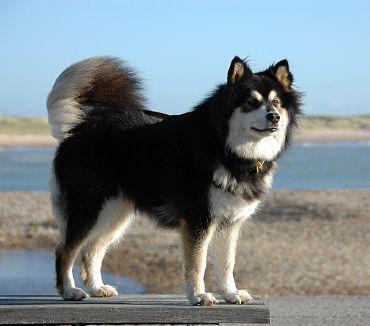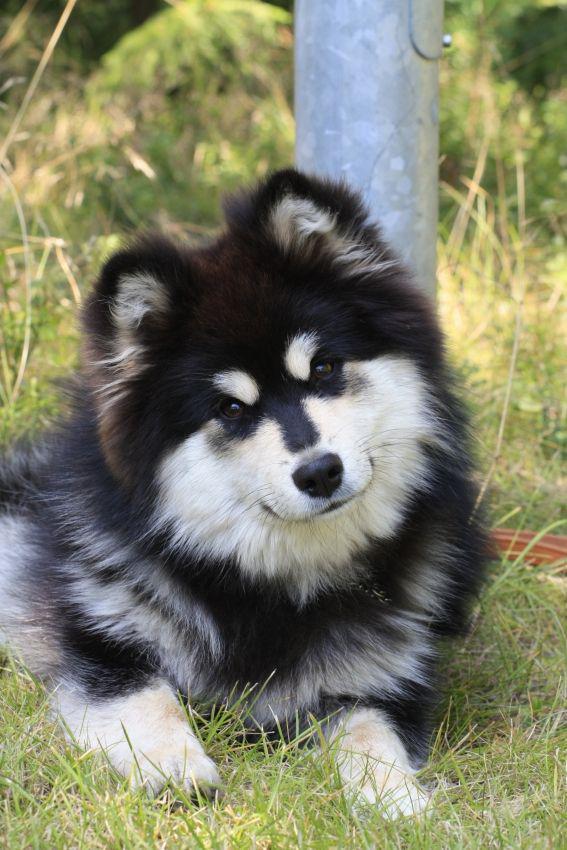The first image is the image on the left, the second image is the image on the right. Given the left and right images, does the statement "The left image contains exactly one dog." hold true? Answer yes or no. Yes. The first image is the image on the left, the second image is the image on the right. For the images displayed, is the sentence "One of the images shows a body of water in the background." factually correct? Answer yes or no. Yes. 